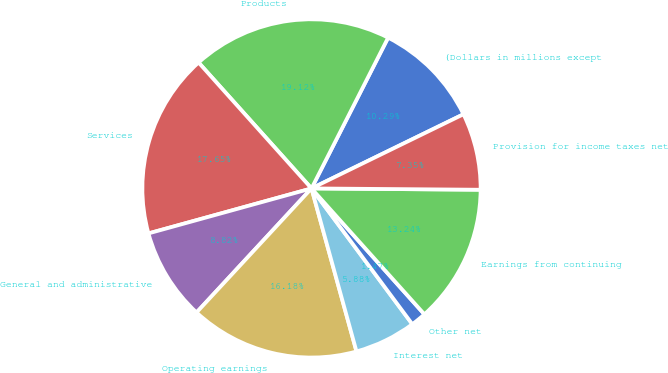Convert chart to OTSL. <chart><loc_0><loc_0><loc_500><loc_500><pie_chart><fcel>(Dollars in millions except<fcel>Products<fcel>Services<fcel>General and administrative<fcel>Operating earnings<fcel>Interest net<fcel>Other net<fcel>Earnings from continuing<fcel>Provision for income taxes net<nl><fcel>10.29%<fcel>19.12%<fcel>17.65%<fcel>8.82%<fcel>16.18%<fcel>5.88%<fcel>1.47%<fcel>13.24%<fcel>7.35%<nl></chart> 